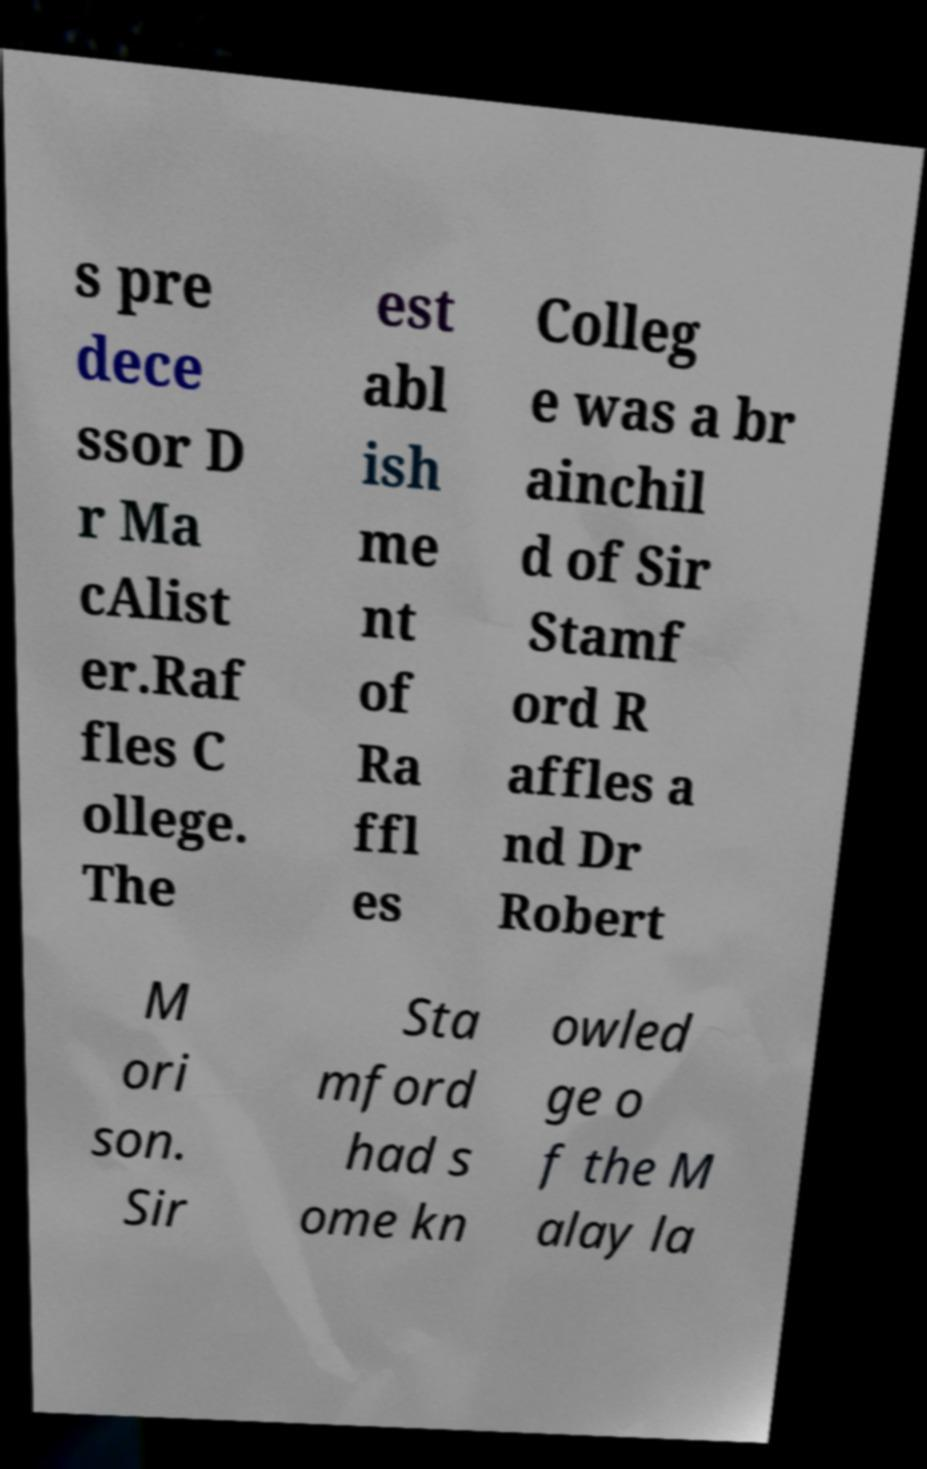Can you accurately transcribe the text from the provided image for me? s pre dece ssor D r Ma cAlist er.Raf fles C ollege. The est abl ish me nt of Ra ffl es Colleg e was a br ainchil d of Sir Stamf ord R affles a nd Dr Robert M ori son. Sir Sta mford had s ome kn owled ge o f the M alay la 